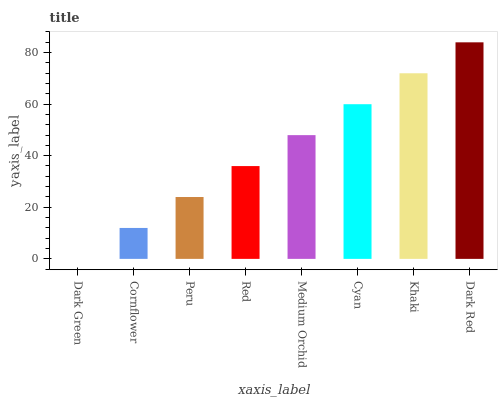Is Dark Green the minimum?
Answer yes or no. Yes. Is Dark Red the maximum?
Answer yes or no. Yes. Is Cornflower the minimum?
Answer yes or no. No. Is Cornflower the maximum?
Answer yes or no. No. Is Cornflower greater than Dark Green?
Answer yes or no. Yes. Is Dark Green less than Cornflower?
Answer yes or no. Yes. Is Dark Green greater than Cornflower?
Answer yes or no. No. Is Cornflower less than Dark Green?
Answer yes or no. No. Is Medium Orchid the high median?
Answer yes or no. Yes. Is Red the low median?
Answer yes or no. Yes. Is Red the high median?
Answer yes or no. No. Is Dark Green the low median?
Answer yes or no. No. 